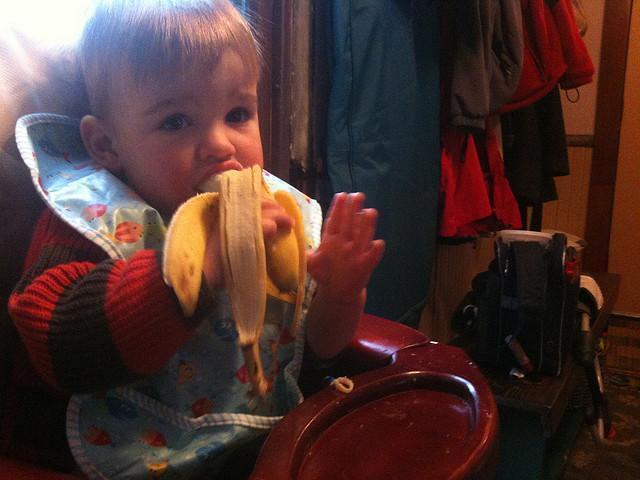Why is he wearing a bib?
Make your selection from the four choices given to correctly answer the question.
Options: Helps sleep, store things, protect clothing, stylish. Protect clothing. 